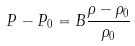<formula> <loc_0><loc_0><loc_500><loc_500>P - P _ { 0 } = B \frac { \rho - \rho _ { 0 } } { \rho _ { 0 } }</formula> 